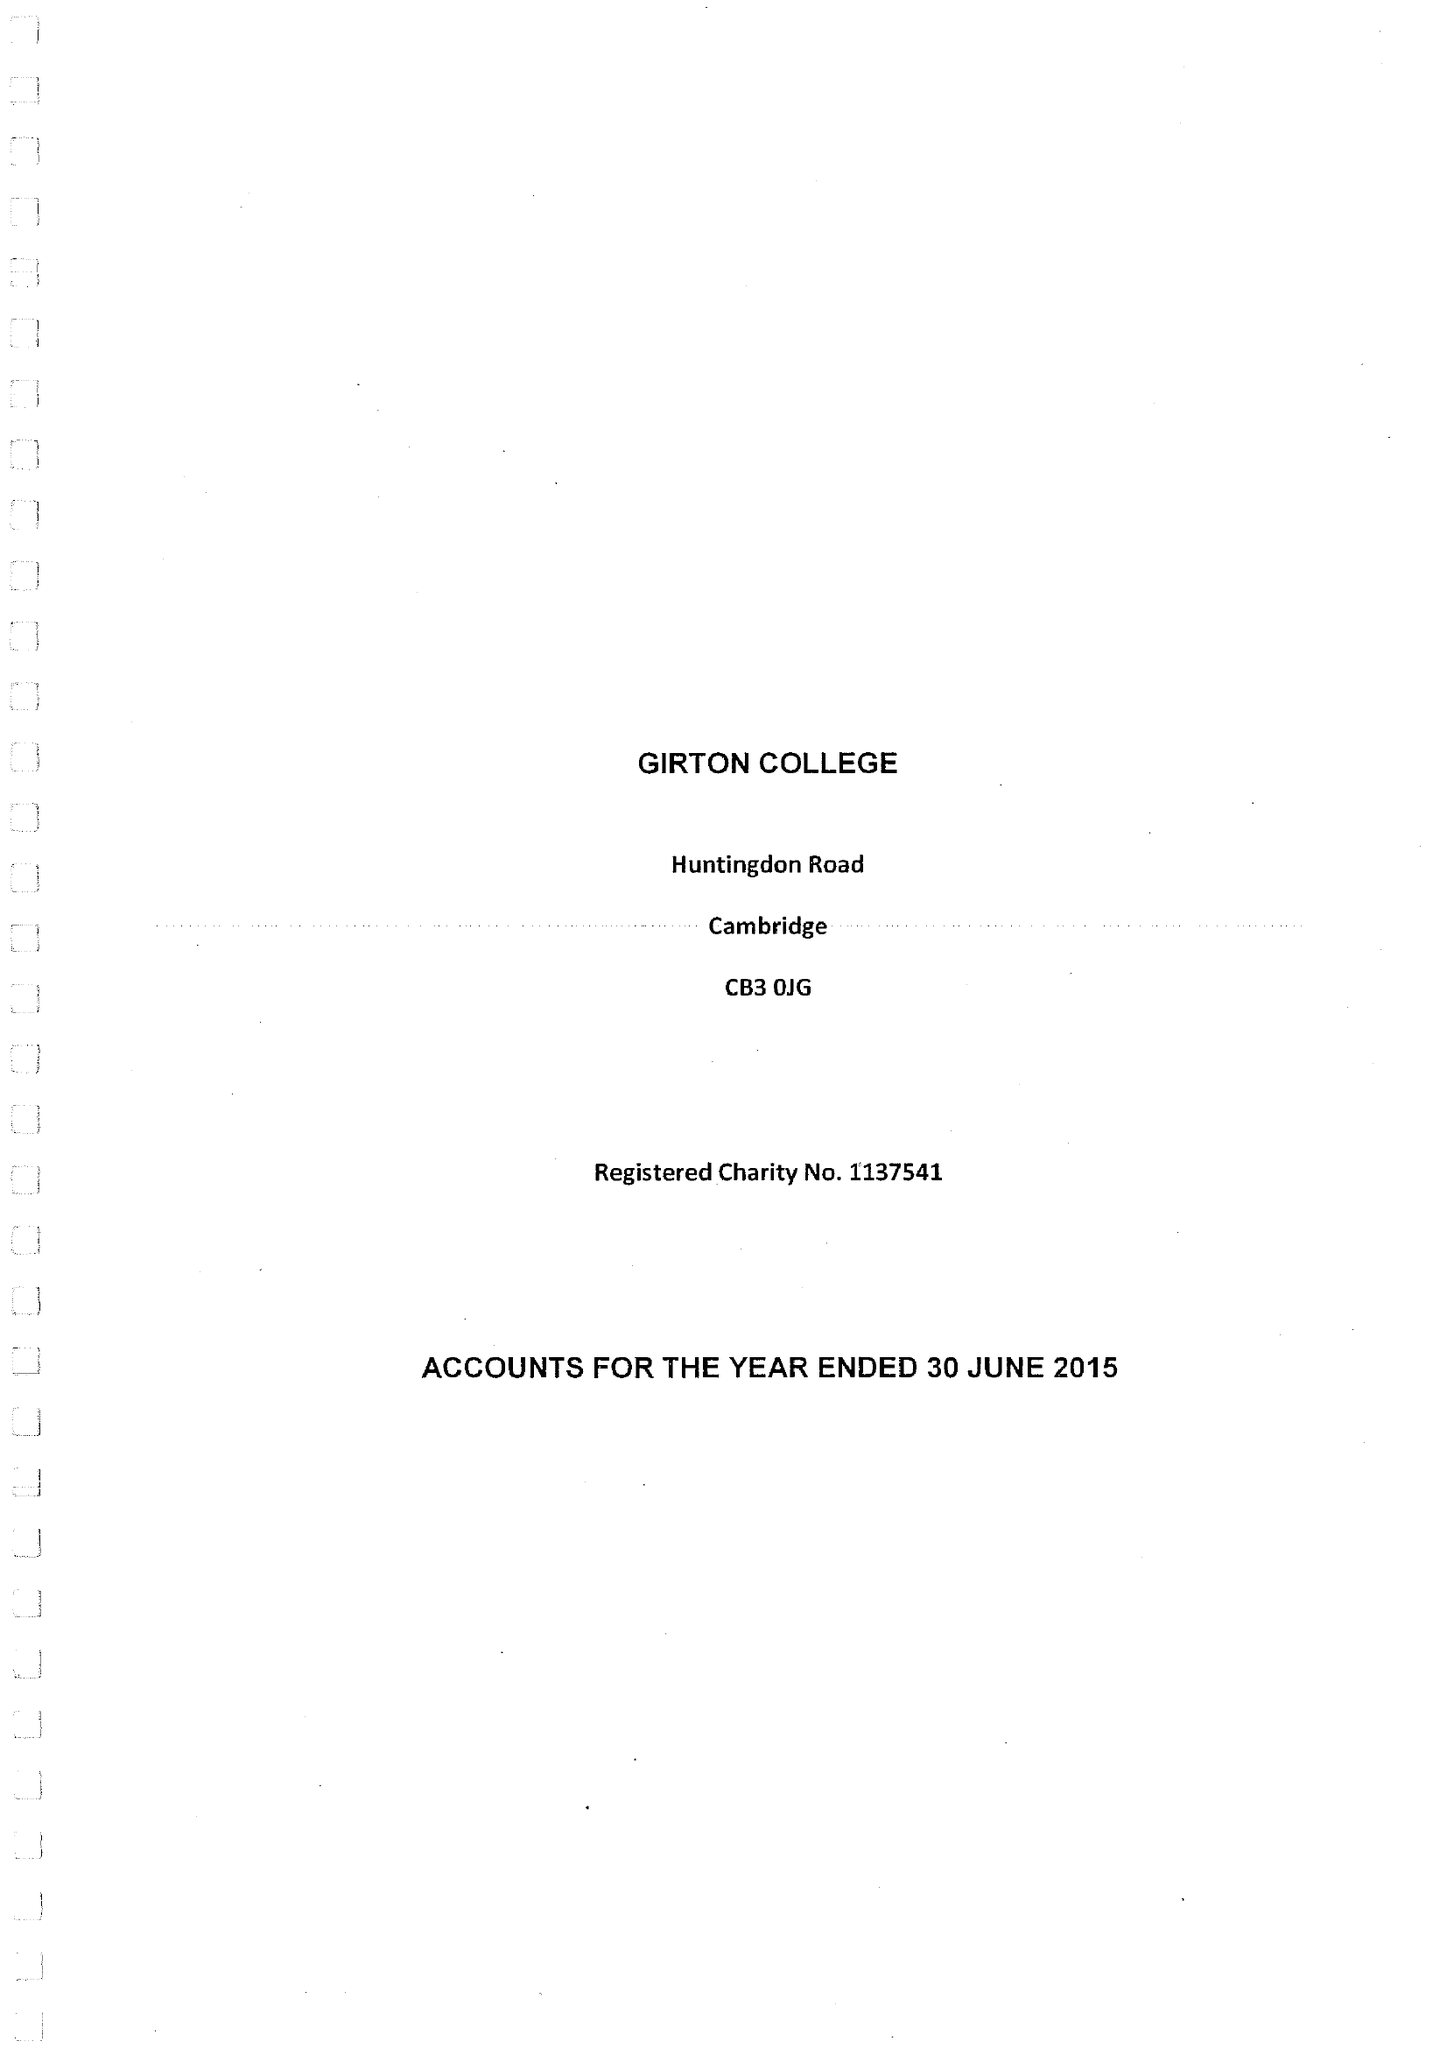What is the value for the charity_name?
Answer the question using a single word or phrase. Girton College 